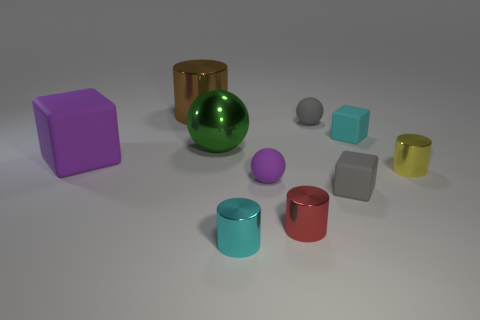Does the cyan metal cylinder have the same size as the purple thing on the left side of the large shiny ball? no 